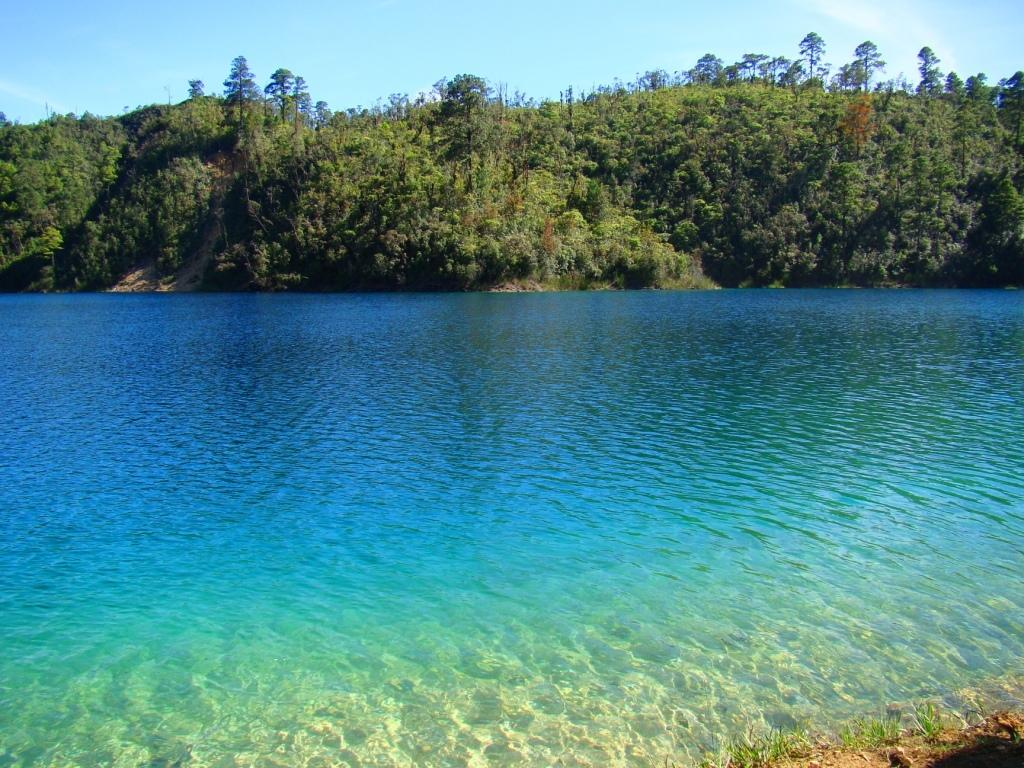What is the main subject in the center of the image? There is water in the center of the image. What can be seen in the background of the image? There are trees and the sky visible in the background of the image. How many cherries are hanging from the trees in the image? There are no cherries mentioned or visible in the image; it only features water, trees, and the sky. 